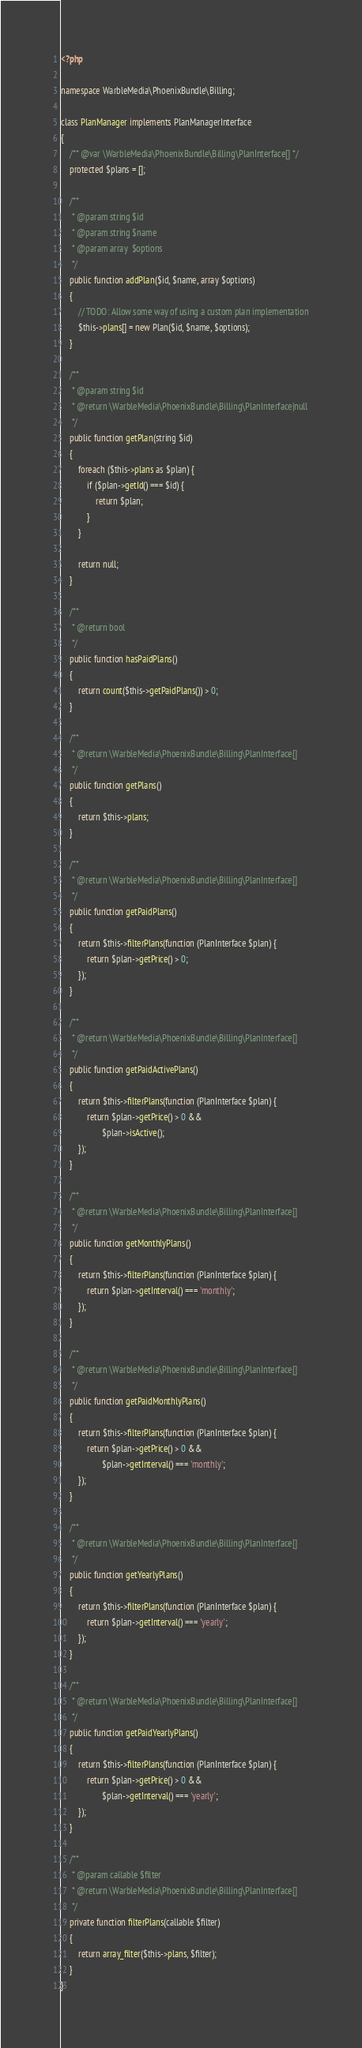Convert code to text. <code><loc_0><loc_0><loc_500><loc_500><_PHP_><?php

namespace WarbleMedia\PhoenixBundle\Billing;

class PlanManager implements PlanManagerInterface
{
    /** @var \WarbleMedia\PhoenixBundle\Billing\PlanInterface[] */
    protected $plans = [];

    /**
     * @param string $id
     * @param string $name
     * @param array  $options
     */
    public function addPlan($id, $name, array $options)
    {
        // TODO: Allow some way of using a custom plan implementation
        $this->plans[] = new Plan($id, $name, $options);
    }

    /**
     * @param string $id
     * @return \WarbleMedia\PhoenixBundle\Billing\PlanInterface|null
     */
    public function getPlan(string $id)
    {
        foreach ($this->plans as $plan) {
            if ($plan->getId() === $id) {
                return $plan;
            }
        }

        return null;
    }

    /**
     * @return bool
     */
    public function hasPaidPlans()
    {
        return count($this->getPaidPlans()) > 0;
    }

    /**
     * @return \WarbleMedia\PhoenixBundle\Billing\PlanInterface[]
     */
    public function getPlans()
    {
        return $this->plans;
    }

    /**
     * @return \WarbleMedia\PhoenixBundle\Billing\PlanInterface[]
     */
    public function getPaidPlans()
    {
        return $this->filterPlans(function (PlanInterface $plan) {
            return $plan->getPrice() > 0;
        });
    }

    /**
     * @return \WarbleMedia\PhoenixBundle\Billing\PlanInterface[]
     */
    public function getPaidActivePlans()
    {
        return $this->filterPlans(function (PlanInterface $plan) {
            return $plan->getPrice() > 0 &&
                   $plan->isActive();
        });
    }

    /**
     * @return \WarbleMedia\PhoenixBundle\Billing\PlanInterface[]
     */
    public function getMonthlyPlans()
    {
        return $this->filterPlans(function (PlanInterface $plan) {
            return $plan->getInterval() === 'monthly';
        });
    }

    /**
     * @return \WarbleMedia\PhoenixBundle\Billing\PlanInterface[]
     */
    public function getPaidMonthlyPlans()
    {
        return $this->filterPlans(function (PlanInterface $plan) {
            return $plan->getPrice() > 0 &&
                   $plan->getInterval() === 'monthly';
        });
    }

    /**
     * @return \WarbleMedia\PhoenixBundle\Billing\PlanInterface[]
     */
    public function getYearlyPlans()
    {
        return $this->filterPlans(function (PlanInterface $plan) {
            return $plan->getInterval() === 'yearly';
        });
    }

    /**
     * @return \WarbleMedia\PhoenixBundle\Billing\PlanInterface[]
     */
    public function getPaidYearlyPlans()
    {
        return $this->filterPlans(function (PlanInterface $plan) {
            return $plan->getPrice() > 0 &&
                   $plan->getInterval() === 'yearly';
        });
    }

    /**
     * @param callable $filter
     * @return \WarbleMedia\PhoenixBundle\Billing\PlanInterface[]
     */
    private function filterPlans(callable $filter)
    {
        return array_filter($this->plans, $filter);
    }
}
</code> 